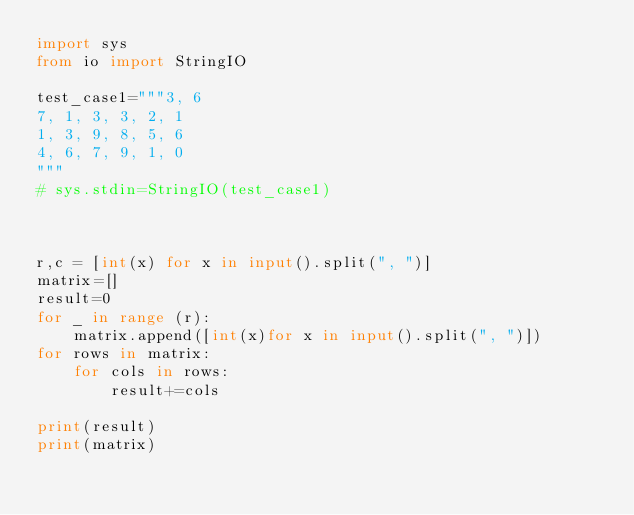Convert code to text. <code><loc_0><loc_0><loc_500><loc_500><_Python_>import sys
from io import StringIO

test_case1="""3, 6
7, 1, 3, 3, 2, 1
1, 3, 9, 8, 5, 6
4, 6, 7, 9, 1, 0
"""
# sys.stdin=StringIO(test_case1)



r,c = [int(x) for x in input().split(", ")]
matrix=[]
result=0
for _ in range (r):
    matrix.append([int(x)for x in input().split(", ")])
for rows in matrix:
    for cols in rows:
        result+=cols

print(result)
print(matrix)


</code> 